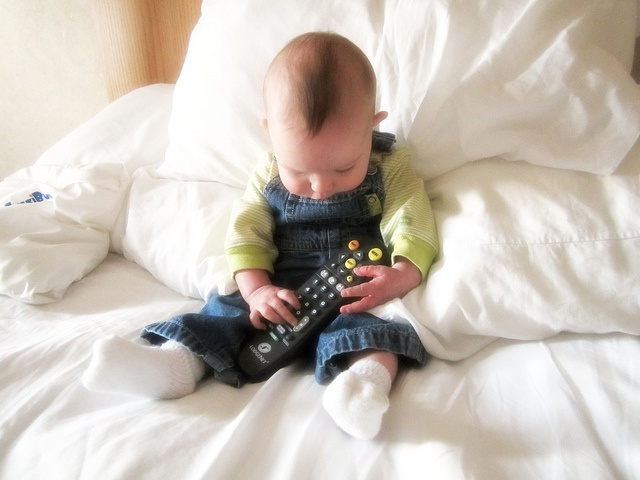Describe the objects in this image and their specific colors. I can see bed in ivory, white, tan, and lightgray tones, bed in ivory, white, lightgray, tan, and darkgray tones, people in ivory, black, lightgray, brown, and tan tones, and remote in ivory, black, gray, and darkgray tones in this image. 